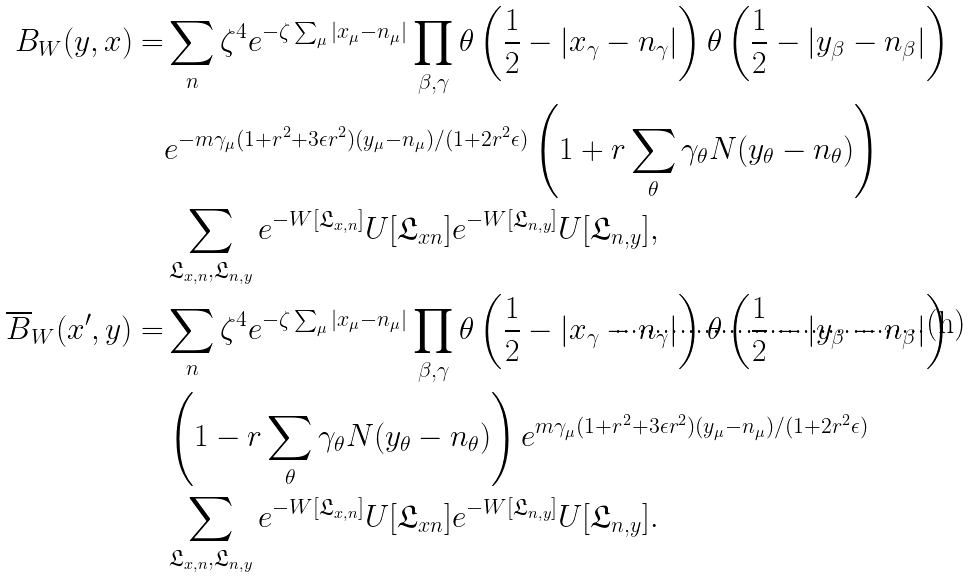<formula> <loc_0><loc_0><loc_500><loc_500>B _ { W } ( y , x ) = & \sum _ { n } \zeta ^ { 4 } e ^ { - \zeta \sum _ { \mu } | x _ { \mu } - n _ { \mu } | } \prod _ { \beta , \gamma } \theta \left ( \frac { 1 } { 2 } - | x _ { \gamma } - n _ { \gamma } | \right ) \theta \left ( \frac { 1 } { 2 } - | y _ { \beta } - n _ { \beta } | \right ) \\ & e ^ { - m \gamma _ { \mu } ( 1 + r ^ { 2 } + 3 \epsilon r ^ { 2 } ) ( y _ { \mu } - n _ { \mu } ) / ( 1 + 2 r ^ { 2 } \epsilon ) } \left ( 1 + r \sum _ { \theta } \gamma _ { \theta } N ( y _ { \theta } - n _ { \theta } ) \right ) \\ & \sum _ { \mathfrak { L } _ { x , n } , \mathfrak { L } _ { n , y } } e ^ { - W [ \mathfrak { L } _ { x , n } ] } U [ \mathfrak { L } _ { x n } ] e ^ { - W [ \mathfrak { L } _ { n , y } ] } U [ \mathfrak { L } _ { n , y } ] , \\ \overline { B } _ { W } ( x ^ { \prime } , y ) = & \sum _ { n } \zeta ^ { 4 } e ^ { - \zeta \sum _ { \mu } | x _ { \mu } - n _ { \mu } | } \prod _ { \beta , \gamma } \theta \left ( \frac { 1 } { 2 } - | x _ { \gamma } - n _ { \gamma } | \right ) \theta \left ( \frac { 1 } { 2 } - | y _ { \beta } - n _ { \beta } | \right ) \\ & \left ( 1 - r \sum _ { \theta } \gamma _ { \theta } N ( y _ { \theta } - n _ { \theta } ) \right ) e ^ { m \gamma _ { \mu } ( 1 + r ^ { 2 } + 3 \epsilon r ^ { 2 } ) ( y _ { \mu } - n _ { \mu } ) / ( 1 + 2 r ^ { 2 } \epsilon ) } \\ & \sum _ { \mathfrak { L } _ { x , n } , \mathfrak { L } _ { n , y } } e ^ { - W [ \mathfrak { L } _ { x , n } ] } U [ \mathfrak { L } _ { x n } ] e ^ { - W [ \mathfrak { L } _ { n , y } ] } U [ \mathfrak { L } _ { n , y } ] .</formula> 